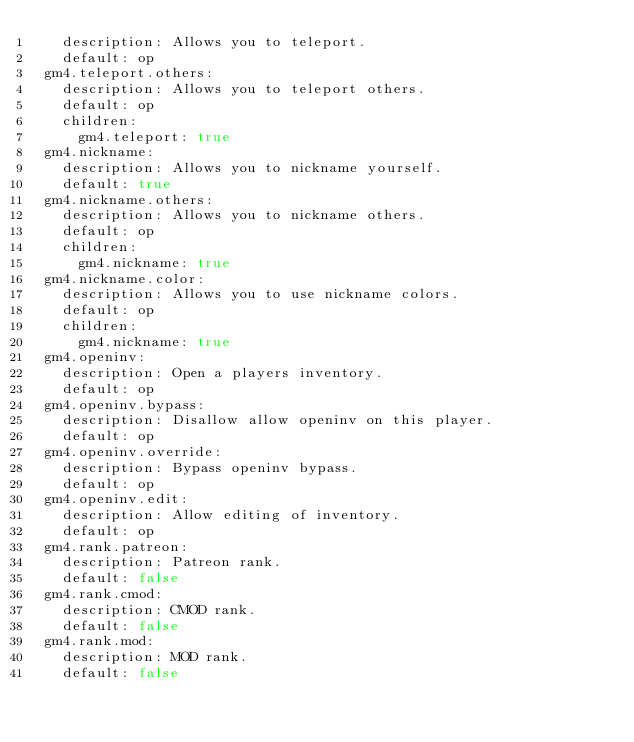Convert code to text. <code><loc_0><loc_0><loc_500><loc_500><_YAML_>   description: Allows you to teleport.
   default: op
 gm4.teleport.others:
   description: Allows you to teleport others.
   default: op
   children:
     gm4.teleport: true
 gm4.nickname:
   description: Allows you to nickname yourself.
   default: true
 gm4.nickname.others:
   description: Allows you to nickname others.
   default: op
   children:
     gm4.nickname: true
 gm4.nickname.color:
   description: Allows you to use nickname colors.
   default: op
   children:
     gm4.nickname: true
 gm4.openinv:
   description: Open a players inventory.
   default: op
 gm4.openinv.bypass:
   description: Disallow allow openinv on this player.
   default: op
 gm4.openinv.override:
   description: Bypass openinv bypass.
   default: op
 gm4.openinv.edit:
   description: Allow editing of inventory.
   default: op
 gm4.rank.patreon:
   description: Patreon rank.
   default: false
 gm4.rank.cmod:
   description: CMOD rank.
   default: false
 gm4.rank.mod:
   description: MOD rank.
   default: false</code> 